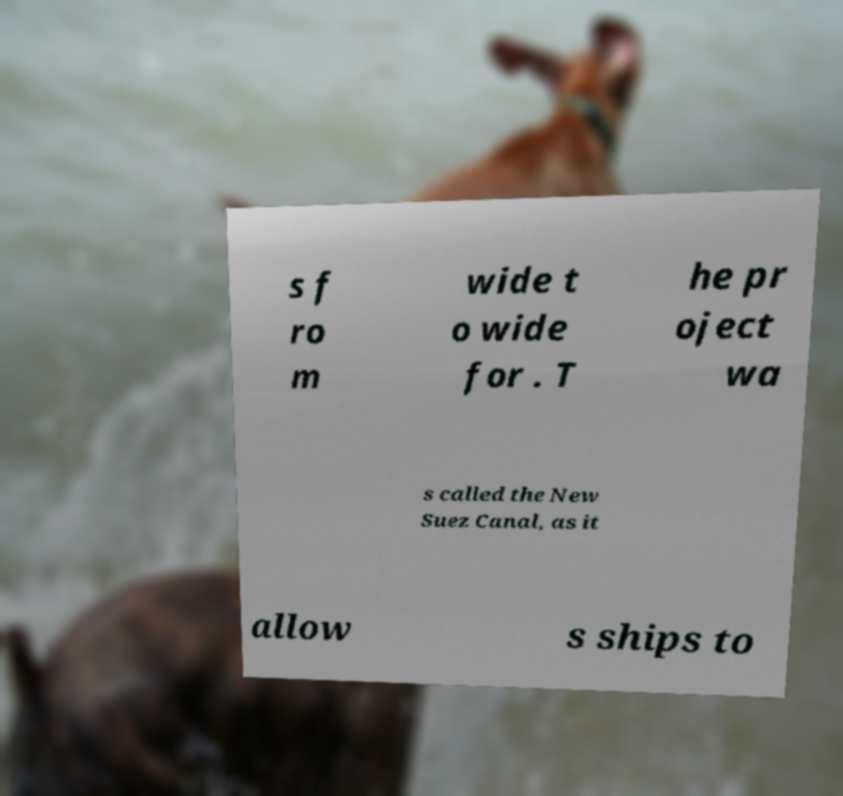I need the written content from this picture converted into text. Can you do that? s f ro m wide t o wide for . T he pr oject wa s called the New Suez Canal, as it allow s ships to 